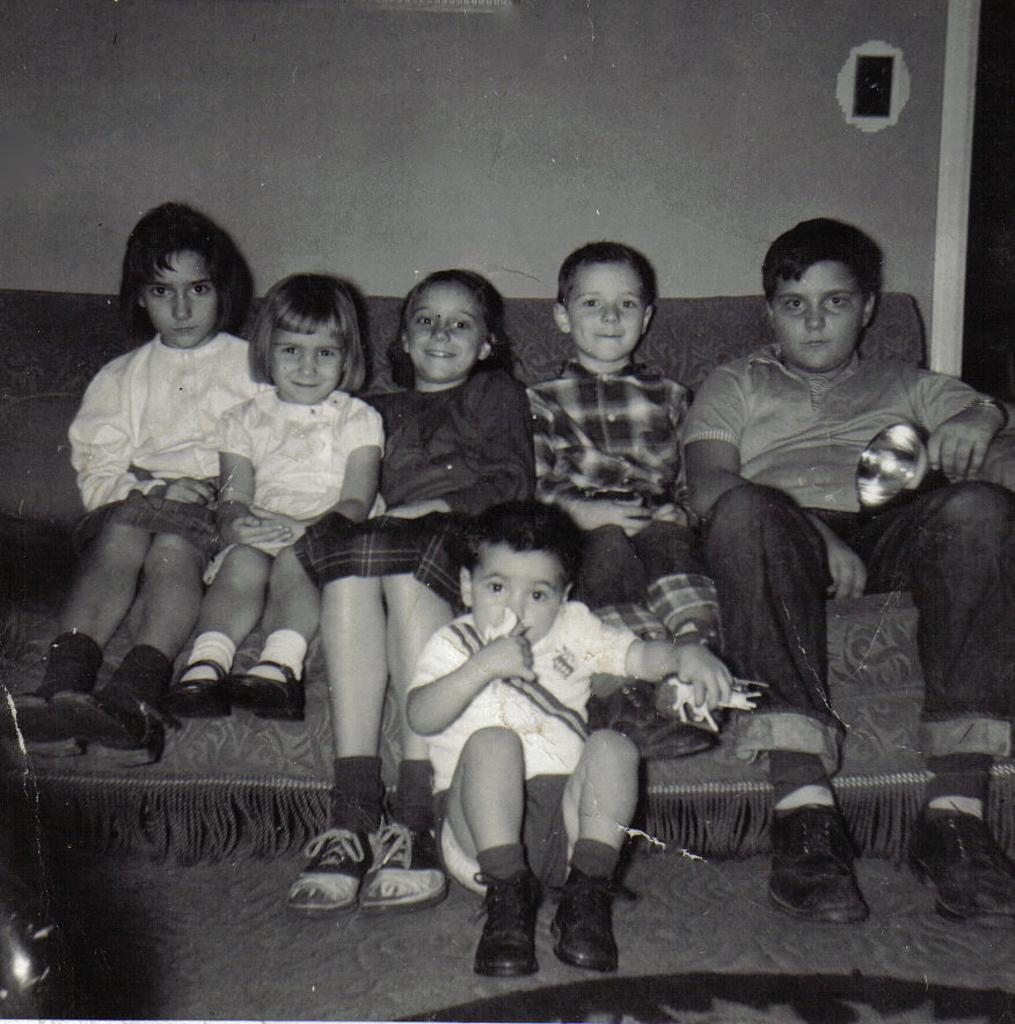What are the children in the image doing? The children are sitting on a couch in the image. Can you describe the position of one of the children? There is a child sitting on the floor in the image. What is the child on the floor holding? The child on the floor is holding an object. What can be seen on the wall in the background of the image? There is an object on the wall in the background of the image. What is the rate of the waves crashing on the coast in the image? There is no coast or waves present in the image; it features children sitting on a couch and on the floor. 